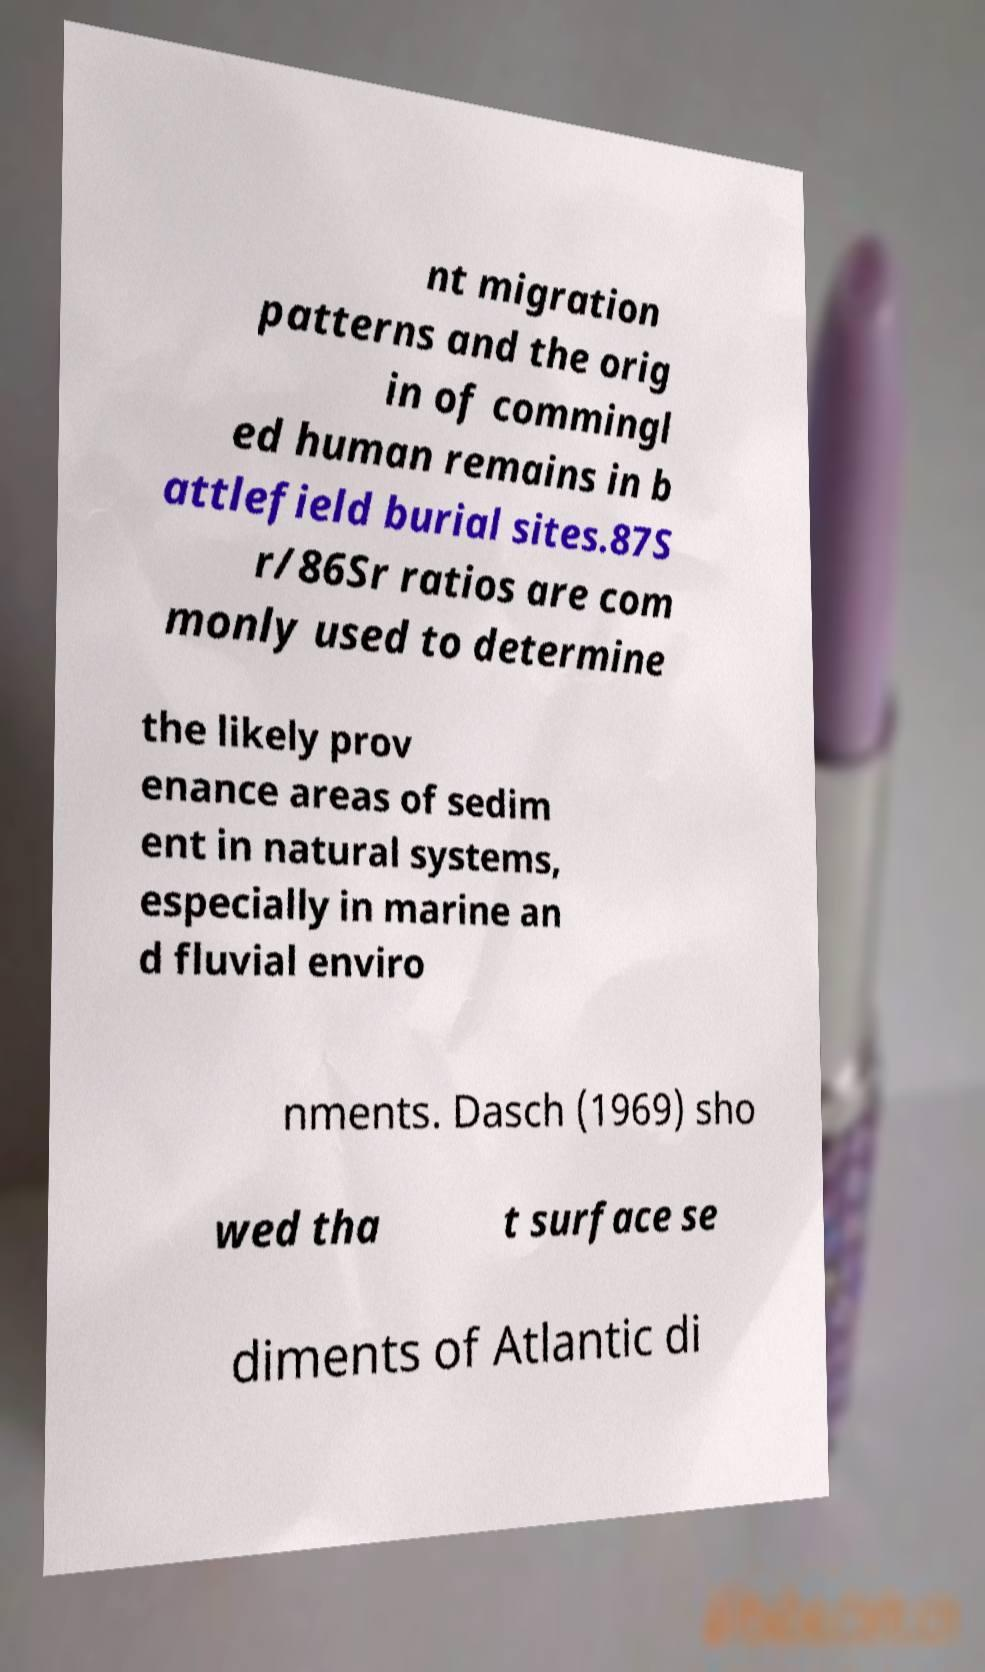Please read and relay the text visible in this image. What does it say? nt migration patterns and the orig in of commingl ed human remains in b attlefield burial sites.87S r/86Sr ratios are com monly used to determine the likely prov enance areas of sedim ent in natural systems, especially in marine an d fluvial enviro nments. Dasch (1969) sho wed tha t surface se diments of Atlantic di 